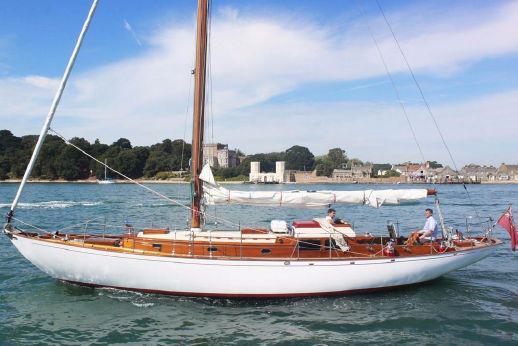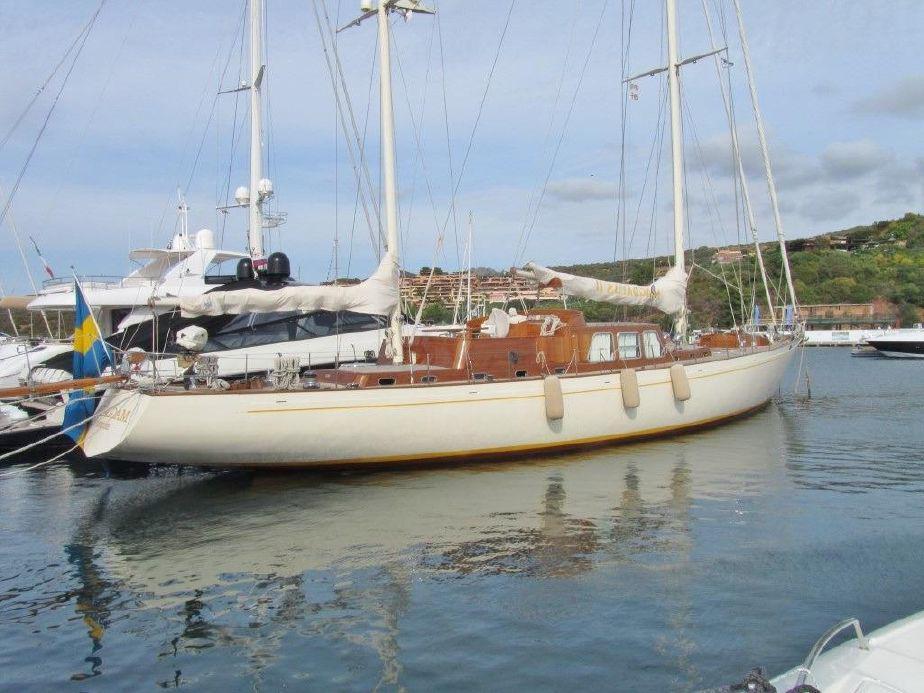The first image is the image on the left, the second image is the image on the right. Analyze the images presented: Is the assertion "Both sailboats have furled white sails." valid? Answer yes or no. Yes. The first image is the image on the left, the second image is the image on the right. Considering the images on both sides, is "All images show white-bodied boats, and no boat has its sails unfurled." valid? Answer yes or no. Yes. 